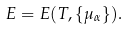Convert formula to latex. <formula><loc_0><loc_0><loc_500><loc_500>E = E ( T , \{ \mu _ { \alpha } \} ) .</formula> 